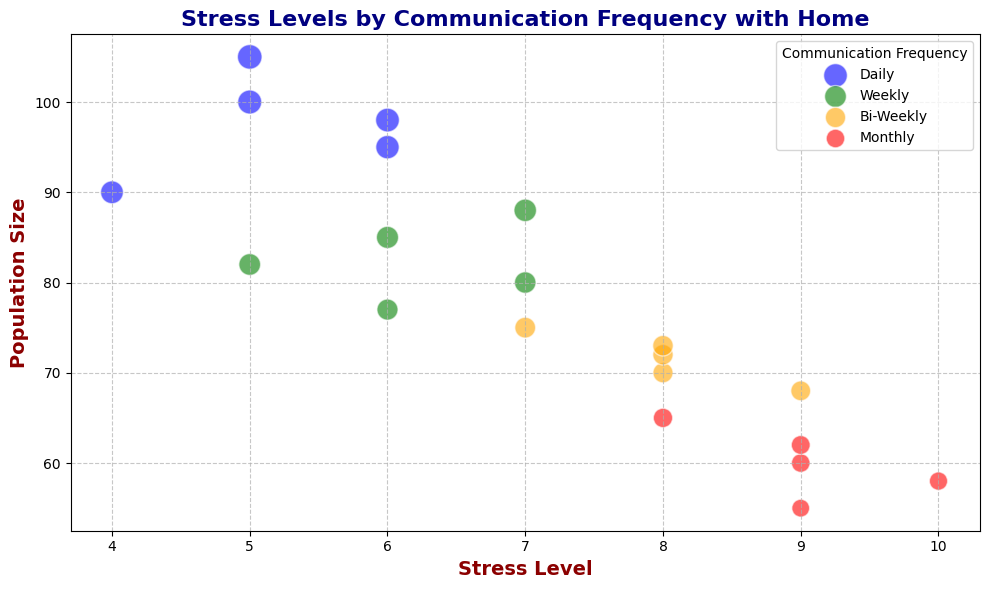How does the median stress level of the "Monthly" communication group compare to the "Weekly" communication group? First, observe the stress levels. For "Monthly": [9, 8, 9, 9, 10]. The median is 9. For "Weekly": [7, 6, 5, 6, 7]. The median is 6. As 9 > 6, "Monthly" has a higher median stress level.
Answer: Monthly group has a higher median stress level Which communication frequency shows the largest population size with a stress level of 9? Check which communication frequency has the largest bubble size at a stress level of 9. The "Monthly" group has bubbles at (9, 58), (9, 60), and (9, 62) compared to other groups. The largest population size is 62.
Answer: Monthly Which group has the highest stress levels overall, and what are these levels for each frequency? Examine the maximum stress level for each communication frequency. "Daily" appears up to 6, "Weekly" up to 7, "Bi-Weekly" up to 9, and "Monthly" up to 10.
Answer: Monthly group, levels are 8, 9, 10 Are there any "Bi-Weekly" data points with a stress level higher than the highest stress level in the "Daily" group? The highest stress levels in "Daily" are 6. For "Bi-Weekly," the levels are 7, 8, 9. Since some of these are higher than 6, the answer is yes.
Answer: Yes What is the average population size of the "Weekly" group? Population sizes for "Weekly" are: 80, 85, 82, 77, 88. The sum is 412, and there are 5 data points. Average = 412/5 = 82.4.
Answer: 82.4 Which communication frequency group has the densest cluster of bubbles in terms of population size? Compare the bubble sizes' clustering for each frequency. "Daily" and "Weekly" tend to have many similar-sized small bubbles, while "Monthly" has larger but fewer bubbles, indicating higher density in the "Daily" and "Weekly" groups.
Answer: Daily and Weekly 